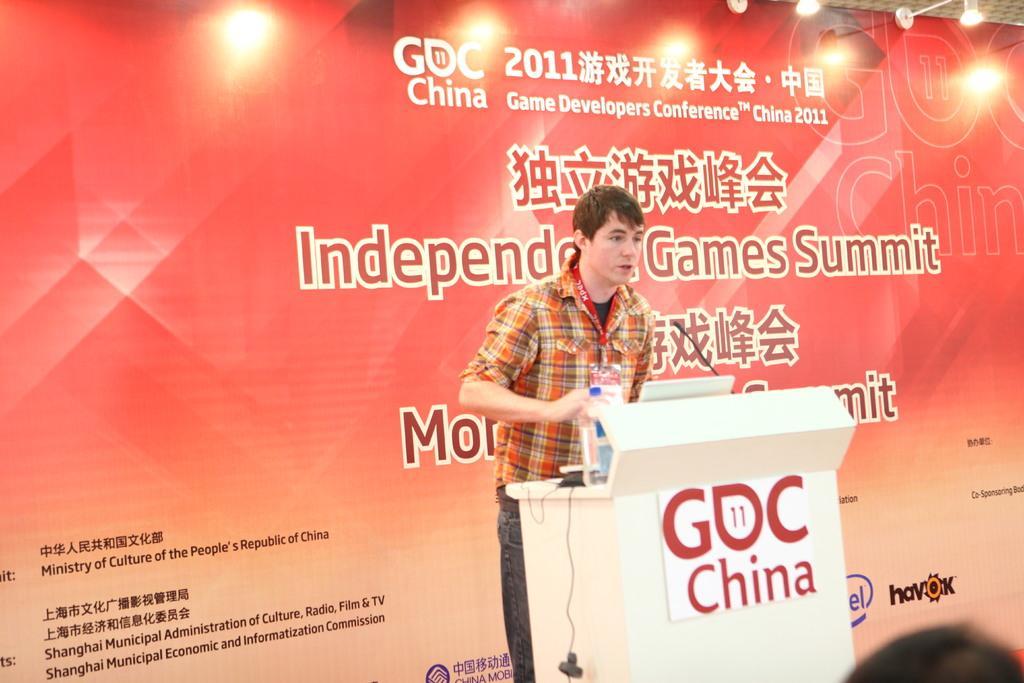Could you give a brief overview of what you see in this image? In this picture there is a person standing behind the podium and talking. There is a bottle, laptop, microphone on the podium. At the back there is a hoarding and there is a text on the hoarding. At the top there are lights. In the bottom right there is a person. 